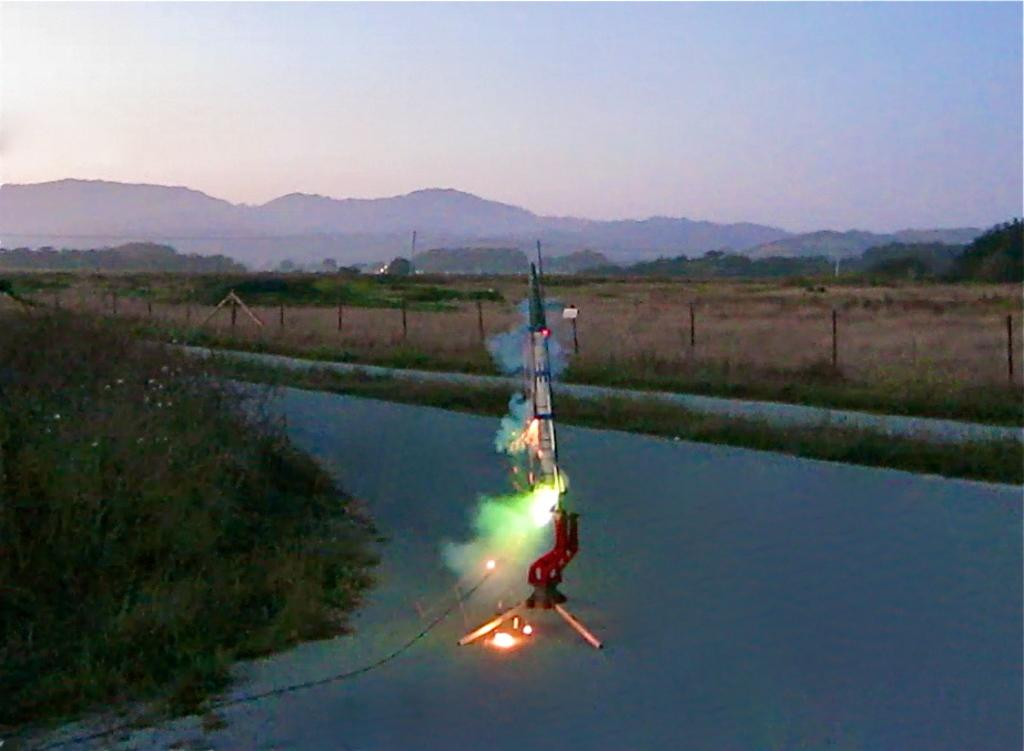What is the main subject of the image? There is a rocket on the road in the image. What can be seen on the left side of the image? There are trees on the left side of the image. What is visible in the background of the image? In the background of the image, there are rods, trees, mountains, and the sky. What type of amusement can be seen in the image? There is no amusement present in the image; it features a rocket on the road and various elements in the background. What substance is being used to fuel the rocket in the image? The image does not provide information about the fuel or substance being used for the rocket. 